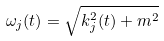Convert formula to latex. <formula><loc_0><loc_0><loc_500><loc_500>\omega _ { j } ( t ) = \sqrt { k _ { j } ^ { 2 } ( t ) + m ^ { 2 } }</formula> 